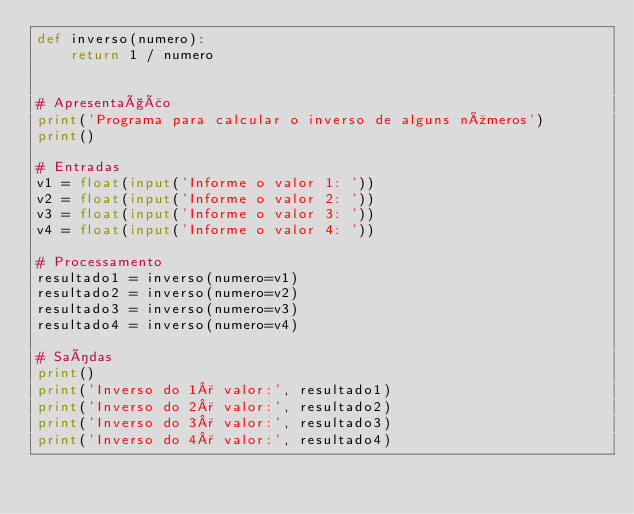<code> <loc_0><loc_0><loc_500><loc_500><_Python_>def inverso(numero):
    return 1 / numero


# Apresentação
print('Programa para calcular o inverso de alguns números')
print()

# Entradas
v1 = float(input('Informe o valor 1: '))
v2 = float(input('Informe o valor 2: '))
v3 = float(input('Informe o valor 3: '))
v4 = float(input('Informe o valor 4: '))

# Processamento
resultado1 = inverso(numero=v1)
resultado2 = inverso(numero=v2)
resultado3 = inverso(numero=v3)
resultado4 = inverso(numero=v4)

# Saídas
print()
print('Inverso do 1° valor:', resultado1)
print('Inverso do 2° valor:', resultado2)
print('Inverso do 3° valor:', resultado3)
print('Inverso do 4° valor:', resultado4)
</code> 